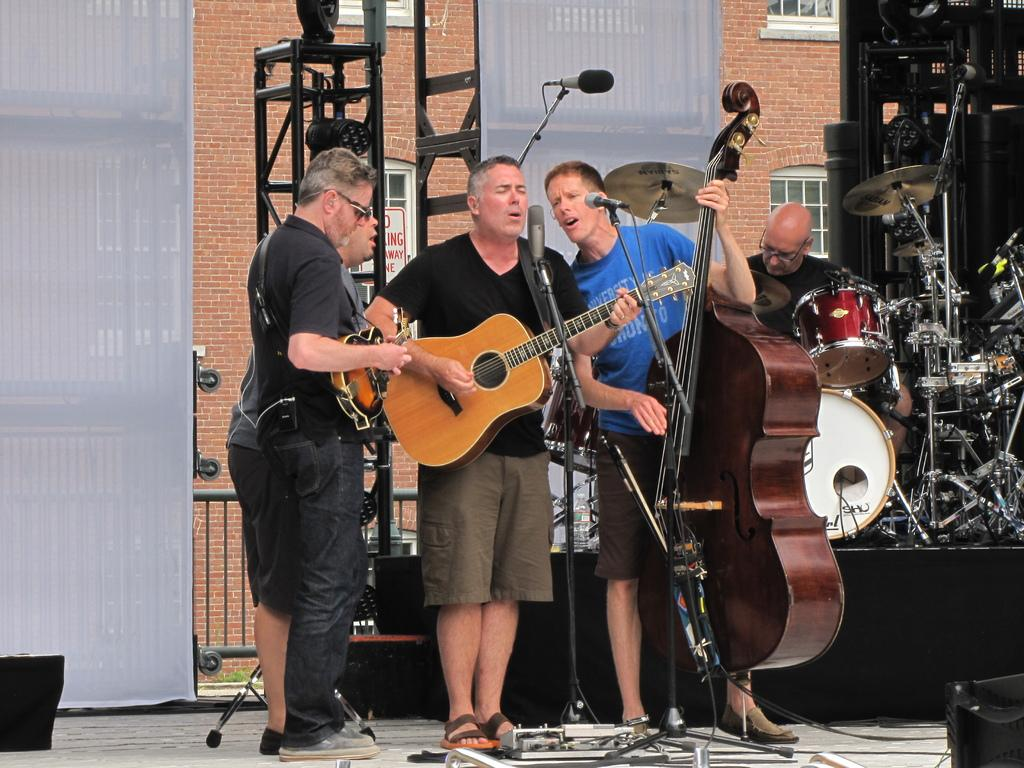How many people are in the image? There are 5 men in the image. What are some of the men doing in the image? Four of the men are holding instruments, and two of them are near microphones. What can be seen in the background of the image? There is a building in the background of the image. What type of discovery was made in the cave in the image? There is no cave present in the image, so no discovery can be made in a cave. 